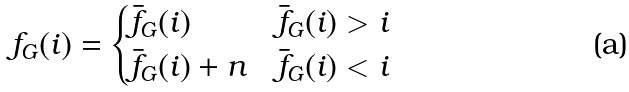<formula> <loc_0><loc_0><loc_500><loc_500>f _ { G } ( i ) = \begin{cases} \bar { f } _ { G } ( i ) & \bar { f } _ { G } ( i ) > i \\ \bar { f } _ { G } ( i ) + n & \bar { f } _ { G } ( i ) < i \end{cases}</formula> 